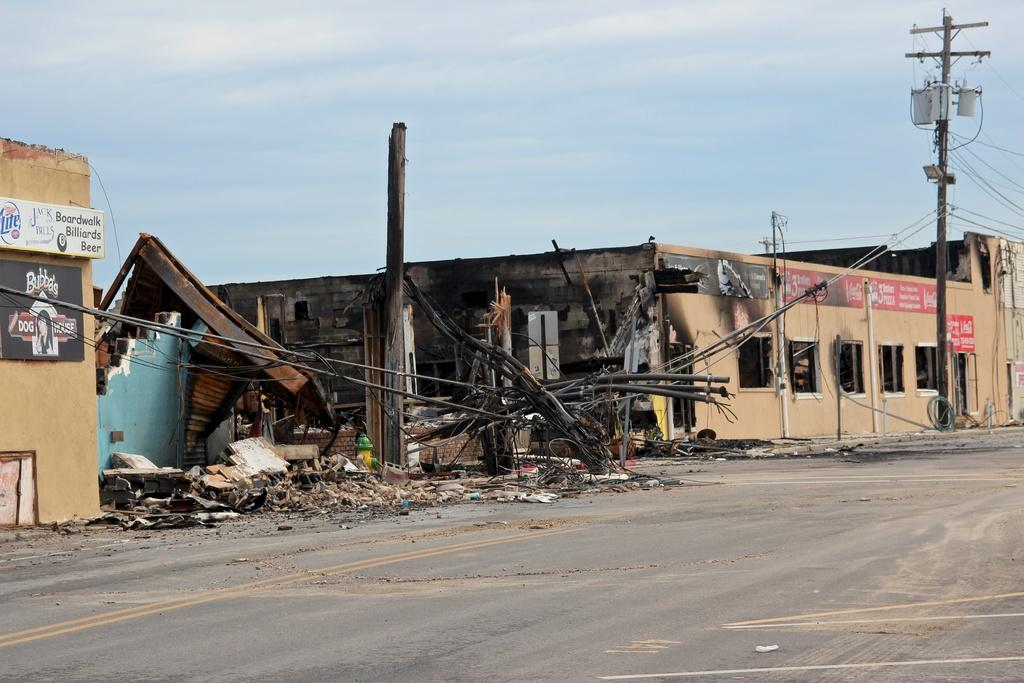What type of structures can be seen in the image? There are houses in the image. What else can be seen in the image besides the houses? There are poles, wires, boards with text, a broken wall, and objects on the ground visible in the image. Can you describe the ground in the image? The ground is visible in the image, and there are objects on it. What is visible in the sky in the image? The sky is visible in the image, and there are clouds in it. What type of bun is being used to drive the car in the image? There is no car or bun present in the image. What part of the houses is missing in the image? There is no information about missing parts of the houses in the image. 